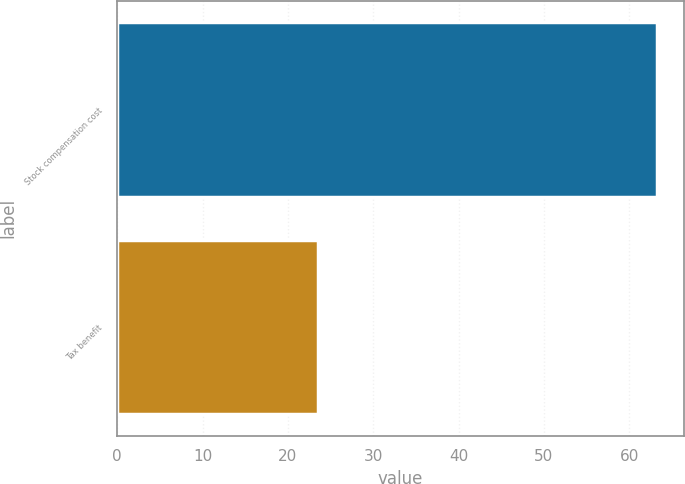Convert chart to OTSL. <chart><loc_0><loc_0><loc_500><loc_500><bar_chart><fcel>Stock compensation cost<fcel>Tax benefit<nl><fcel>63.2<fcel>23.5<nl></chart> 